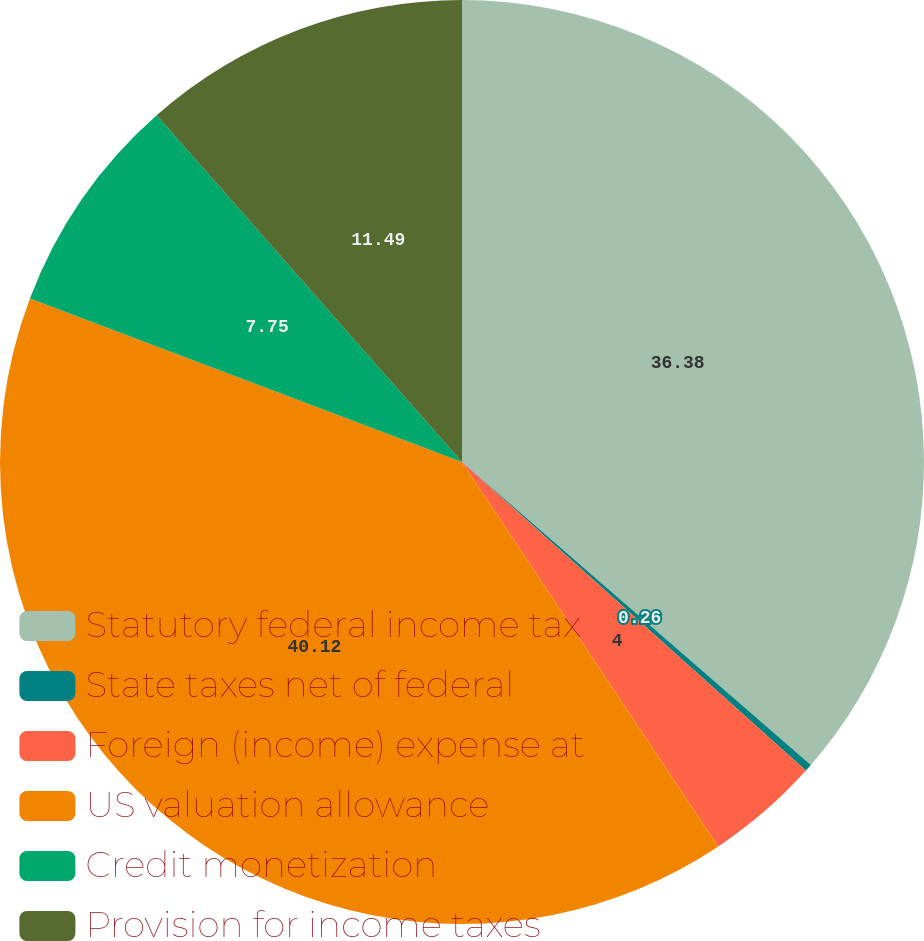Convert chart. <chart><loc_0><loc_0><loc_500><loc_500><pie_chart><fcel>Statutory federal income tax<fcel>State taxes net of federal<fcel>Foreign (income) expense at<fcel>US valuation allowance<fcel>Credit monetization<fcel>Provision for income taxes<nl><fcel>36.38%<fcel>0.26%<fcel>4.0%<fcel>40.12%<fcel>7.75%<fcel>11.49%<nl></chart> 